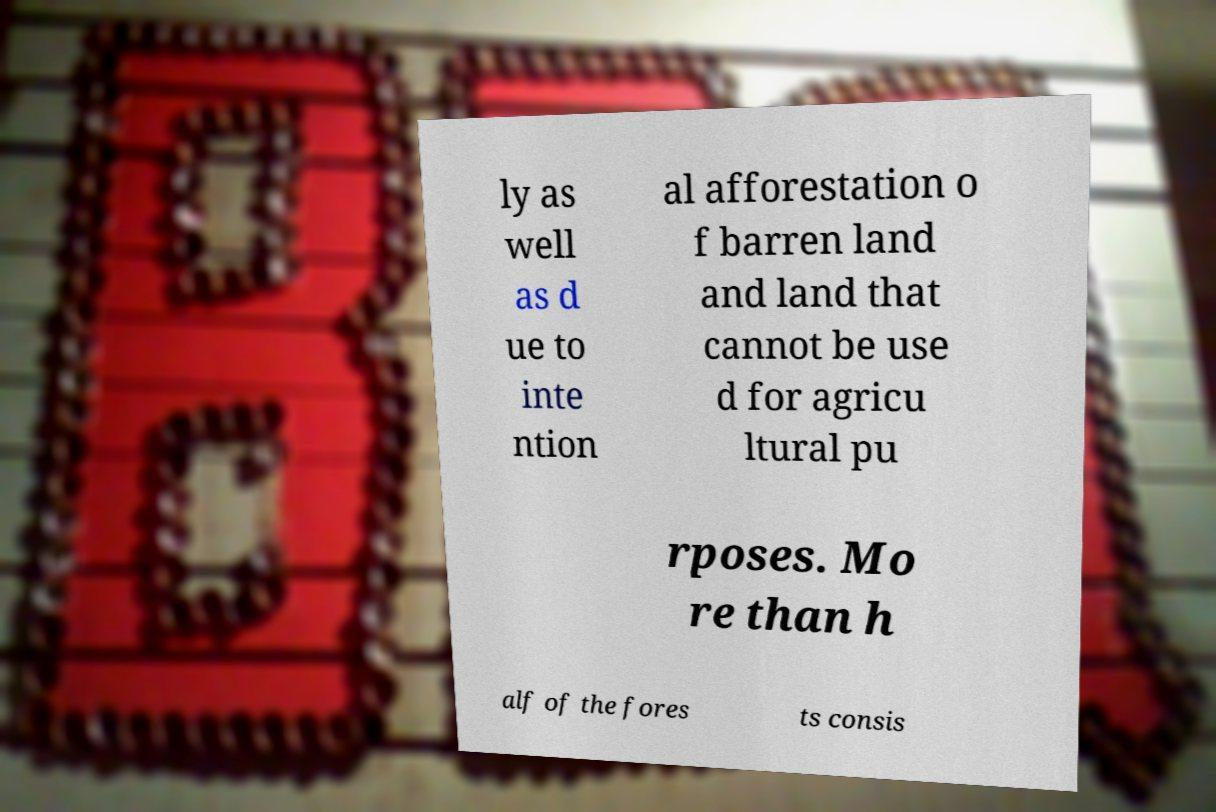I need the written content from this picture converted into text. Can you do that? ly as well as d ue to inte ntion al afforestation o f barren land and land that cannot be use d for agricu ltural pu rposes. Mo re than h alf of the fores ts consis 